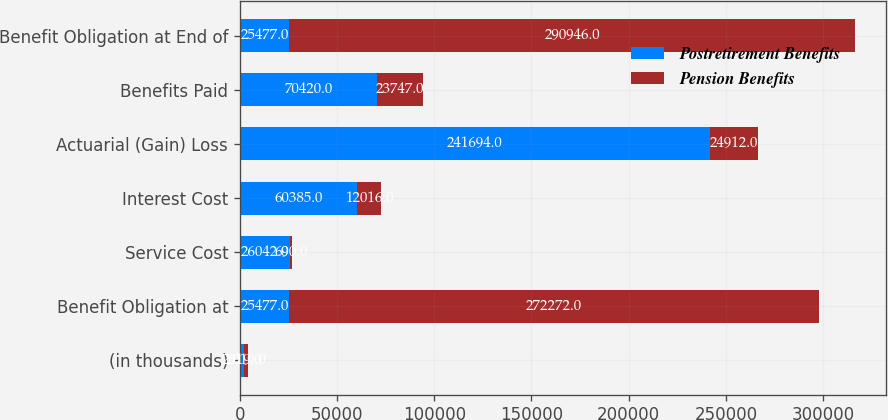Convert chart to OTSL. <chart><loc_0><loc_0><loc_500><loc_500><stacked_bar_chart><ecel><fcel>(in thousands)<fcel>Benefit Obligation at<fcel>Service Cost<fcel>Interest Cost<fcel>Actuarial (Gain) Loss<fcel>Benefits Paid<fcel>Benefit Obligation at End of<nl><fcel>Postretirement Benefits<fcel>2019<fcel>25477<fcel>26042<fcel>60385<fcel>241694<fcel>70420<fcel>25477<nl><fcel>Pension Benefits<fcel>2019<fcel>272272<fcel>690<fcel>12016<fcel>24912<fcel>23747<fcel>290946<nl></chart> 